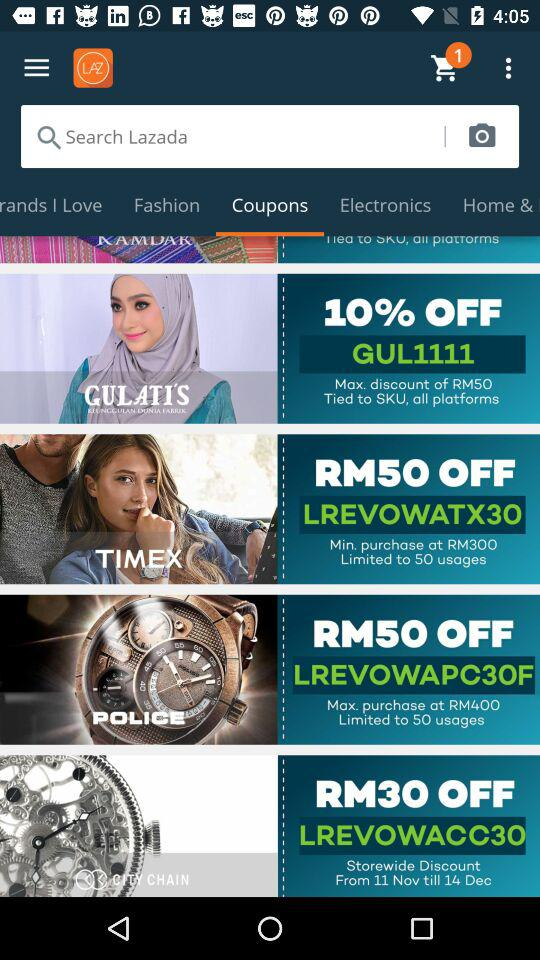Which coupon has the highest RM discount?
Answer the question using a single word or phrase. RM50 OFF 